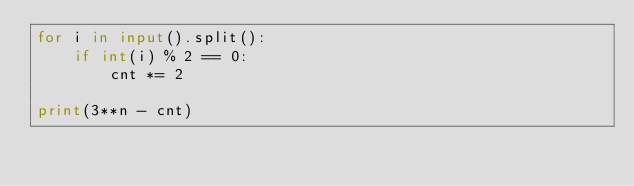<code> <loc_0><loc_0><loc_500><loc_500><_Python_>for i in input().split():
    if int(i) % 2 == 0:
        cnt *= 2

print(3**n - cnt)</code> 